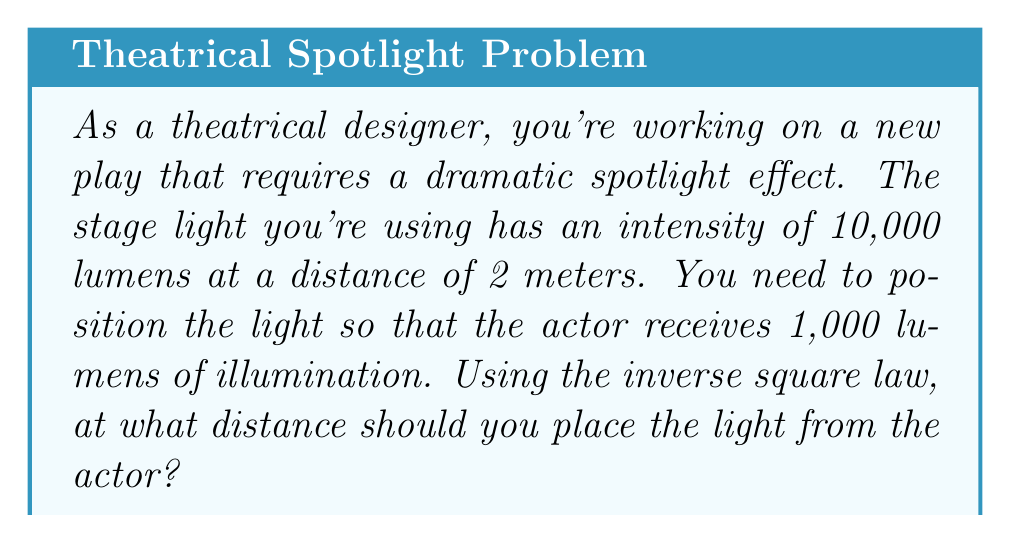Could you help me with this problem? Let's approach this step-by-step using the inverse square law:

1) The inverse square law for light intensity states that:

   $$ I_2 = I_1 \cdot \left(\frac{d_1}{d_2}\right)^2 $$

   Where:
   $I_1$ is the initial intensity
   $I_2$ is the final intensity
   $d_1$ is the initial distance
   $d_2$ is the final distance (what we're solving for)

2) We know:
   $I_1 = 10,000$ lumens
   $I_2 = 1,000$ lumens
   $d_1 = 2$ meters
   $d_2$ is unknown

3) Let's plug these values into our equation:

   $$ 1,000 = 10,000 \cdot \left(\frac{2}{d_2}\right)^2 $$

4) Simplify the right side:

   $$ 1,000 = \frac{40,000}{d_2^2} $$

5) Multiply both sides by $d_2^2$:

   $$ 1,000d_2^2 = 40,000 $$

6) Divide both sides by 1,000:

   $$ d_2^2 = 40 $$

7) Take the square root of both sides:

   $$ d_2 = \sqrt{40} = 2\sqrt{10} \approx 6.32 $$

Therefore, the light should be placed approximately 6.32 meters from the actor.
Answer: $d_2 = 2\sqrt{10} \approx 6.32$ meters 